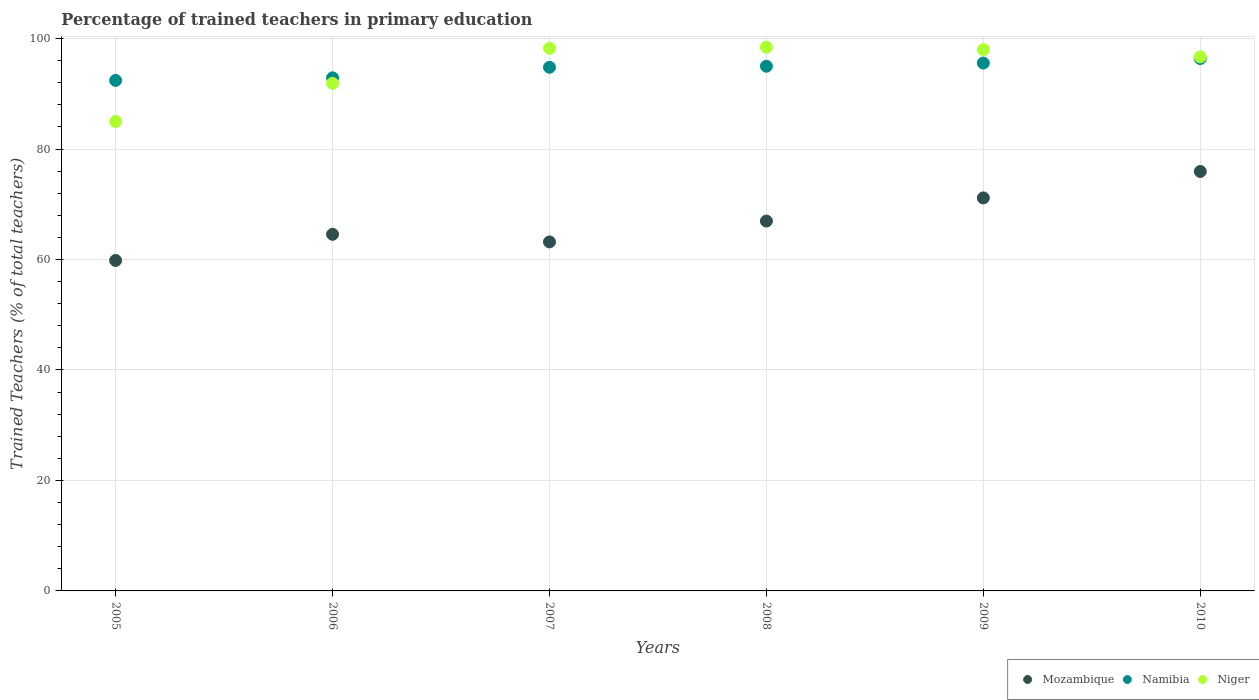Is the number of dotlines equal to the number of legend labels?
Ensure brevity in your answer.  Yes. What is the percentage of trained teachers in Mozambique in 2009?
Give a very brief answer. 71.16. Across all years, what is the maximum percentage of trained teachers in Niger?
Make the answer very short. 98.44. Across all years, what is the minimum percentage of trained teachers in Namibia?
Keep it short and to the point. 92.43. What is the total percentage of trained teachers in Namibia in the graph?
Your response must be concise. 567.1. What is the difference between the percentage of trained teachers in Mozambique in 2005 and that in 2008?
Your response must be concise. -7.13. What is the difference between the percentage of trained teachers in Niger in 2005 and the percentage of trained teachers in Mozambique in 2007?
Ensure brevity in your answer.  21.81. What is the average percentage of trained teachers in Namibia per year?
Give a very brief answer. 94.52. In the year 2008, what is the difference between the percentage of trained teachers in Mozambique and percentage of trained teachers in Niger?
Your response must be concise. -31.47. What is the ratio of the percentage of trained teachers in Niger in 2009 to that in 2010?
Your answer should be compact. 1.01. What is the difference between the highest and the second highest percentage of trained teachers in Mozambique?
Your answer should be compact. 4.79. What is the difference between the highest and the lowest percentage of trained teachers in Mozambique?
Offer a terse response. 16.11. Does the percentage of trained teachers in Mozambique monotonically increase over the years?
Offer a terse response. No. How many years are there in the graph?
Your response must be concise. 6. What is the difference between two consecutive major ticks on the Y-axis?
Offer a terse response. 20. Are the values on the major ticks of Y-axis written in scientific E-notation?
Offer a terse response. No. Does the graph contain any zero values?
Your answer should be compact. No. Does the graph contain grids?
Give a very brief answer. Yes. How many legend labels are there?
Your response must be concise. 3. How are the legend labels stacked?
Give a very brief answer. Horizontal. What is the title of the graph?
Provide a short and direct response. Percentage of trained teachers in primary education. Does "Malaysia" appear as one of the legend labels in the graph?
Provide a succinct answer. No. What is the label or title of the X-axis?
Give a very brief answer. Years. What is the label or title of the Y-axis?
Your answer should be very brief. Trained Teachers (% of total teachers). What is the Trained Teachers (% of total teachers) in Mozambique in 2005?
Your answer should be very brief. 59.83. What is the Trained Teachers (% of total teachers) of Namibia in 2005?
Keep it short and to the point. 92.43. What is the Trained Teachers (% of total teachers) of Niger in 2005?
Offer a very short reply. 85. What is the Trained Teachers (% of total teachers) in Mozambique in 2006?
Your answer should be very brief. 64.57. What is the Trained Teachers (% of total teachers) of Namibia in 2006?
Offer a terse response. 92.9. What is the Trained Teachers (% of total teachers) in Niger in 2006?
Keep it short and to the point. 91.91. What is the Trained Teachers (% of total teachers) in Mozambique in 2007?
Your answer should be very brief. 63.19. What is the Trained Teachers (% of total teachers) of Namibia in 2007?
Offer a terse response. 94.81. What is the Trained Teachers (% of total teachers) of Niger in 2007?
Offer a terse response. 98.24. What is the Trained Teachers (% of total teachers) of Mozambique in 2008?
Ensure brevity in your answer.  66.97. What is the Trained Teachers (% of total teachers) in Namibia in 2008?
Your response must be concise. 95. What is the Trained Teachers (% of total teachers) of Niger in 2008?
Your answer should be very brief. 98.44. What is the Trained Teachers (% of total teachers) of Mozambique in 2009?
Your answer should be very brief. 71.16. What is the Trained Teachers (% of total teachers) of Namibia in 2009?
Keep it short and to the point. 95.58. What is the Trained Teachers (% of total teachers) of Niger in 2009?
Your answer should be compact. 98.01. What is the Trained Teachers (% of total teachers) in Mozambique in 2010?
Give a very brief answer. 75.94. What is the Trained Teachers (% of total teachers) of Namibia in 2010?
Offer a terse response. 96.39. What is the Trained Teachers (% of total teachers) of Niger in 2010?
Ensure brevity in your answer.  96.69. Across all years, what is the maximum Trained Teachers (% of total teachers) of Mozambique?
Offer a very short reply. 75.94. Across all years, what is the maximum Trained Teachers (% of total teachers) in Namibia?
Give a very brief answer. 96.39. Across all years, what is the maximum Trained Teachers (% of total teachers) in Niger?
Keep it short and to the point. 98.44. Across all years, what is the minimum Trained Teachers (% of total teachers) in Mozambique?
Ensure brevity in your answer.  59.83. Across all years, what is the minimum Trained Teachers (% of total teachers) of Namibia?
Make the answer very short. 92.43. Across all years, what is the minimum Trained Teachers (% of total teachers) of Niger?
Your response must be concise. 85. What is the total Trained Teachers (% of total teachers) in Mozambique in the graph?
Give a very brief answer. 401.66. What is the total Trained Teachers (% of total teachers) of Namibia in the graph?
Make the answer very short. 567.1. What is the total Trained Teachers (% of total teachers) of Niger in the graph?
Offer a very short reply. 568.29. What is the difference between the Trained Teachers (% of total teachers) of Mozambique in 2005 and that in 2006?
Offer a very short reply. -4.73. What is the difference between the Trained Teachers (% of total teachers) in Namibia in 2005 and that in 2006?
Make the answer very short. -0.47. What is the difference between the Trained Teachers (% of total teachers) in Niger in 2005 and that in 2006?
Ensure brevity in your answer.  -6.91. What is the difference between the Trained Teachers (% of total teachers) of Mozambique in 2005 and that in 2007?
Your answer should be compact. -3.36. What is the difference between the Trained Teachers (% of total teachers) of Namibia in 2005 and that in 2007?
Provide a succinct answer. -2.38. What is the difference between the Trained Teachers (% of total teachers) of Niger in 2005 and that in 2007?
Make the answer very short. -13.24. What is the difference between the Trained Teachers (% of total teachers) in Mozambique in 2005 and that in 2008?
Make the answer very short. -7.13. What is the difference between the Trained Teachers (% of total teachers) of Namibia in 2005 and that in 2008?
Offer a terse response. -2.57. What is the difference between the Trained Teachers (% of total teachers) of Niger in 2005 and that in 2008?
Offer a terse response. -13.44. What is the difference between the Trained Teachers (% of total teachers) of Mozambique in 2005 and that in 2009?
Offer a terse response. -11.32. What is the difference between the Trained Teachers (% of total teachers) in Namibia in 2005 and that in 2009?
Provide a short and direct response. -3.15. What is the difference between the Trained Teachers (% of total teachers) in Niger in 2005 and that in 2009?
Provide a short and direct response. -13.01. What is the difference between the Trained Teachers (% of total teachers) of Mozambique in 2005 and that in 2010?
Your answer should be compact. -16.11. What is the difference between the Trained Teachers (% of total teachers) in Namibia in 2005 and that in 2010?
Make the answer very short. -3.96. What is the difference between the Trained Teachers (% of total teachers) of Niger in 2005 and that in 2010?
Provide a succinct answer. -11.69. What is the difference between the Trained Teachers (% of total teachers) of Mozambique in 2006 and that in 2007?
Make the answer very short. 1.38. What is the difference between the Trained Teachers (% of total teachers) of Namibia in 2006 and that in 2007?
Your answer should be compact. -1.91. What is the difference between the Trained Teachers (% of total teachers) of Niger in 2006 and that in 2007?
Offer a very short reply. -6.33. What is the difference between the Trained Teachers (% of total teachers) in Mozambique in 2006 and that in 2008?
Give a very brief answer. -2.4. What is the difference between the Trained Teachers (% of total teachers) in Namibia in 2006 and that in 2008?
Your response must be concise. -2.1. What is the difference between the Trained Teachers (% of total teachers) of Niger in 2006 and that in 2008?
Make the answer very short. -6.53. What is the difference between the Trained Teachers (% of total teachers) of Mozambique in 2006 and that in 2009?
Provide a succinct answer. -6.59. What is the difference between the Trained Teachers (% of total teachers) in Namibia in 2006 and that in 2009?
Give a very brief answer. -2.68. What is the difference between the Trained Teachers (% of total teachers) in Niger in 2006 and that in 2009?
Your answer should be very brief. -6.11. What is the difference between the Trained Teachers (% of total teachers) in Mozambique in 2006 and that in 2010?
Provide a succinct answer. -11.38. What is the difference between the Trained Teachers (% of total teachers) of Namibia in 2006 and that in 2010?
Provide a succinct answer. -3.49. What is the difference between the Trained Teachers (% of total teachers) of Niger in 2006 and that in 2010?
Offer a terse response. -4.79. What is the difference between the Trained Teachers (% of total teachers) in Mozambique in 2007 and that in 2008?
Make the answer very short. -3.78. What is the difference between the Trained Teachers (% of total teachers) of Namibia in 2007 and that in 2008?
Give a very brief answer. -0.19. What is the difference between the Trained Teachers (% of total teachers) of Niger in 2007 and that in 2008?
Your response must be concise. -0.2. What is the difference between the Trained Teachers (% of total teachers) of Mozambique in 2007 and that in 2009?
Your answer should be compact. -7.97. What is the difference between the Trained Teachers (% of total teachers) of Namibia in 2007 and that in 2009?
Ensure brevity in your answer.  -0.77. What is the difference between the Trained Teachers (% of total teachers) of Niger in 2007 and that in 2009?
Offer a very short reply. 0.22. What is the difference between the Trained Teachers (% of total teachers) of Mozambique in 2007 and that in 2010?
Give a very brief answer. -12.75. What is the difference between the Trained Teachers (% of total teachers) in Namibia in 2007 and that in 2010?
Your answer should be compact. -1.58. What is the difference between the Trained Teachers (% of total teachers) of Niger in 2007 and that in 2010?
Keep it short and to the point. 1.54. What is the difference between the Trained Teachers (% of total teachers) in Mozambique in 2008 and that in 2009?
Provide a short and direct response. -4.19. What is the difference between the Trained Teachers (% of total teachers) of Namibia in 2008 and that in 2009?
Keep it short and to the point. -0.58. What is the difference between the Trained Teachers (% of total teachers) of Niger in 2008 and that in 2009?
Your response must be concise. 0.42. What is the difference between the Trained Teachers (% of total teachers) of Mozambique in 2008 and that in 2010?
Give a very brief answer. -8.98. What is the difference between the Trained Teachers (% of total teachers) of Namibia in 2008 and that in 2010?
Give a very brief answer. -1.39. What is the difference between the Trained Teachers (% of total teachers) in Niger in 2008 and that in 2010?
Offer a very short reply. 1.74. What is the difference between the Trained Teachers (% of total teachers) of Mozambique in 2009 and that in 2010?
Provide a short and direct response. -4.79. What is the difference between the Trained Teachers (% of total teachers) of Namibia in 2009 and that in 2010?
Offer a terse response. -0.81. What is the difference between the Trained Teachers (% of total teachers) of Niger in 2009 and that in 2010?
Make the answer very short. 1.32. What is the difference between the Trained Teachers (% of total teachers) of Mozambique in 2005 and the Trained Teachers (% of total teachers) of Namibia in 2006?
Your response must be concise. -33.07. What is the difference between the Trained Teachers (% of total teachers) of Mozambique in 2005 and the Trained Teachers (% of total teachers) of Niger in 2006?
Your answer should be very brief. -32.08. What is the difference between the Trained Teachers (% of total teachers) of Namibia in 2005 and the Trained Teachers (% of total teachers) of Niger in 2006?
Ensure brevity in your answer.  0.52. What is the difference between the Trained Teachers (% of total teachers) of Mozambique in 2005 and the Trained Teachers (% of total teachers) of Namibia in 2007?
Provide a short and direct response. -34.98. What is the difference between the Trained Teachers (% of total teachers) in Mozambique in 2005 and the Trained Teachers (% of total teachers) in Niger in 2007?
Your answer should be compact. -38.4. What is the difference between the Trained Teachers (% of total teachers) of Namibia in 2005 and the Trained Teachers (% of total teachers) of Niger in 2007?
Ensure brevity in your answer.  -5.81. What is the difference between the Trained Teachers (% of total teachers) in Mozambique in 2005 and the Trained Teachers (% of total teachers) in Namibia in 2008?
Provide a short and direct response. -35.17. What is the difference between the Trained Teachers (% of total teachers) of Mozambique in 2005 and the Trained Teachers (% of total teachers) of Niger in 2008?
Offer a terse response. -38.6. What is the difference between the Trained Teachers (% of total teachers) in Namibia in 2005 and the Trained Teachers (% of total teachers) in Niger in 2008?
Give a very brief answer. -6.01. What is the difference between the Trained Teachers (% of total teachers) of Mozambique in 2005 and the Trained Teachers (% of total teachers) of Namibia in 2009?
Provide a short and direct response. -35.74. What is the difference between the Trained Teachers (% of total teachers) of Mozambique in 2005 and the Trained Teachers (% of total teachers) of Niger in 2009?
Your answer should be very brief. -38.18. What is the difference between the Trained Teachers (% of total teachers) of Namibia in 2005 and the Trained Teachers (% of total teachers) of Niger in 2009?
Give a very brief answer. -5.59. What is the difference between the Trained Teachers (% of total teachers) in Mozambique in 2005 and the Trained Teachers (% of total teachers) in Namibia in 2010?
Your answer should be compact. -36.56. What is the difference between the Trained Teachers (% of total teachers) in Mozambique in 2005 and the Trained Teachers (% of total teachers) in Niger in 2010?
Make the answer very short. -36.86. What is the difference between the Trained Teachers (% of total teachers) of Namibia in 2005 and the Trained Teachers (% of total teachers) of Niger in 2010?
Offer a very short reply. -4.27. What is the difference between the Trained Teachers (% of total teachers) of Mozambique in 2006 and the Trained Teachers (% of total teachers) of Namibia in 2007?
Keep it short and to the point. -30.24. What is the difference between the Trained Teachers (% of total teachers) of Mozambique in 2006 and the Trained Teachers (% of total teachers) of Niger in 2007?
Your answer should be compact. -33.67. What is the difference between the Trained Teachers (% of total teachers) of Namibia in 2006 and the Trained Teachers (% of total teachers) of Niger in 2007?
Provide a short and direct response. -5.34. What is the difference between the Trained Teachers (% of total teachers) of Mozambique in 2006 and the Trained Teachers (% of total teachers) of Namibia in 2008?
Your answer should be very brief. -30.43. What is the difference between the Trained Teachers (% of total teachers) of Mozambique in 2006 and the Trained Teachers (% of total teachers) of Niger in 2008?
Your answer should be very brief. -33.87. What is the difference between the Trained Teachers (% of total teachers) of Namibia in 2006 and the Trained Teachers (% of total teachers) of Niger in 2008?
Ensure brevity in your answer.  -5.54. What is the difference between the Trained Teachers (% of total teachers) of Mozambique in 2006 and the Trained Teachers (% of total teachers) of Namibia in 2009?
Make the answer very short. -31.01. What is the difference between the Trained Teachers (% of total teachers) of Mozambique in 2006 and the Trained Teachers (% of total teachers) of Niger in 2009?
Provide a succinct answer. -33.45. What is the difference between the Trained Teachers (% of total teachers) in Namibia in 2006 and the Trained Teachers (% of total teachers) in Niger in 2009?
Your answer should be very brief. -5.12. What is the difference between the Trained Teachers (% of total teachers) of Mozambique in 2006 and the Trained Teachers (% of total teachers) of Namibia in 2010?
Give a very brief answer. -31.82. What is the difference between the Trained Teachers (% of total teachers) in Mozambique in 2006 and the Trained Teachers (% of total teachers) in Niger in 2010?
Your answer should be very brief. -32.13. What is the difference between the Trained Teachers (% of total teachers) in Namibia in 2006 and the Trained Teachers (% of total teachers) in Niger in 2010?
Offer a very short reply. -3.8. What is the difference between the Trained Teachers (% of total teachers) of Mozambique in 2007 and the Trained Teachers (% of total teachers) of Namibia in 2008?
Keep it short and to the point. -31.81. What is the difference between the Trained Teachers (% of total teachers) in Mozambique in 2007 and the Trained Teachers (% of total teachers) in Niger in 2008?
Keep it short and to the point. -35.25. What is the difference between the Trained Teachers (% of total teachers) of Namibia in 2007 and the Trained Teachers (% of total teachers) of Niger in 2008?
Your answer should be compact. -3.63. What is the difference between the Trained Teachers (% of total teachers) in Mozambique in 2007 and the Trained Teachers (% of total teachers) in Namibia in 2009?
Give a very brief answer. -32.38. What is the difference between the Trained Teachers (% of total teachers) of Mozambique in 2007 and the Trained Teachers (% of total teachers) of Niger in 2009?
Provide a short and direct response. -34.82. What is the difference between the Trained Teachers (% of total teachers) of Namibia in 2007 and the Trained Teachers (% of total teachers) of Niger in 2009?
Ensure brevity in your answer.  -3.21. What is the difference between the Trained Teachers (% of total teachers) of Mozambique in 2007 and the Trained Teachers (% of total teachers) of Namibia in 2010?
Offer a very short reply. -33.2. What is the difference between the Trained Teachers (% of total teachers) of Mozambique in 2007 and the Trained Teachers (% of total teachers) of Niger in 2010?
Offer a very short reply. -33.5. What is the difference between the Trained Teachers (% of total teachers) of Namibia in 2007 and the Trained Teachers (% of total teachers) of Niger in 2010?
Give a very brief answer. -1.89. What is the difference between the Trained Teachers (% of total teachers) of Mozambique in 2008 and the Trained Teachers (% of total teachers) of Namibia in 2009?
Offer a terse response. -28.61. What is the difference between the Trained Teachers (% of total teachers) of Mozambique in 2008 and the Trained Teachers (% of total teachers) of Niger in 2009?
Keep it short and to the point. -31.05. What is the difference between the Trained Teachers (% of total teachers) in Namibia in 2008 and the Trained Teachers (% of total teachers) in Niger in 2009?
Give a very brief answer. -3.02. What is the difference between the Trained Teachers (% of total teachers) of Mozambique in 2008 and the Trained Teachers (% of total teachers) of Namibia in 2010?
Your answer should be compact. -29.42. What is the difference between the Trained Teachers (% of total teachers) of Mozambique in 2008 and the Trained Teachers (% of total teachers) of Niger in 2010?
Provide a short and direct response. -29.73. What is the difference between the Trained Teachers (% of total teachers) of Namibia in 2008 and the Trained Teachers (% of total teachers) of Niger in 2010?
Make the answer very short. -1.7. What is the difference between the Trained Teachers (% of total teachers) in Mozambique in 2009 and the Trained Teachers (% of total teachers) in Namibia in 2010?
Make the answer very short. -25.23. What is the difference between the Trained Teachers (% of total teachers) in Mozambique in 2009 and the Trained Teachers (% of total teachers) in Niger in 2010?
Provide a short and direct response. -25.54. What is the difference between the Trained Teachers (% of total teachers) in Namibia in 2009 and the Trained Teachers (% of total teachers) in Niger in 2010?
Make the answer very short. -1.12. What is the average Trained Teachers (% of total teachers) of Mozambique per year?
Your response must be concise. 66.94. What is the average Trained Teachers (% of total teachers) of Namibia per year?
Your answer should be very brief. 94.52. What is the average Trained Teachers (% of total teachers) of Niger per year?
Ensure brevity in your answer.  94.72. In the year 2005, what is the difference between the Trained Teachers (% of total teachers) in Mozambique and Trained Teachers (% of total teachers) in Namibia?
Give a very brief answer. -32.59. In the year 2005, what is the difference between the Trained Teachers (% of total teachers) in Mozambique and Trained Teachers (% of total teachers) in Niger?
Your response must be concise. -25.17. In the year 2005, what is the difference between the Trained Teachers (% of total teachers) in Namibia and Trained Teachers (% of total teachers) in Niger?
Make the answer very short. 7.43. In the year 2006, what is the difference between the Trained Teachers (% of total teachers) in Mozambique and Trained Teachers (% of total teachers) in Namibia?
Your response must be concise. -28.33. In the year 2006, what is the difference between the Trained Teachers (% of total teachers) in Mozambique and Trained Teachers (% of total teachers) in Niger?
Offer a terse response. -27.34. In the year 2006, what is the difference between the Trained Teachers (% of total teachers) in Namibia and Trained Teachers (% of total teachers) in Niger?
Keep it short and to the point. 0.99. In the year 2007, what is the difference between the Trained Teachers (% of total teachers) in Mozambique and Trained Teachers (% of total teachers) in Namibia?
Your answer should be compact. -31.62. In the year 2007, what is the difference between the Trained Teachers (% of total teachers) of Mozambique and Trained Teachers (% of total teachers) of Niger?
Ensure brevity in your answer.  -35.04. In the year 2007, what is the difference between the Trained Teachers (% of total teachers) in Namibia and Trained Teachers (% of total teachers) in Niger?
Keep it short and to the point. -3.43. In the year 2008, what is the difference between the Trained Teachers (% of total teachers) in Mozambique and Trained Teachers (% of total teachers) in Namibia?
Your response must be concise. -28.03. In the year 2008, what is the difference between the Trained Teachers (% of total teachers) in Mozambique and Trained Teachers (% of total teachers) in Niger?
Provide a short and direct response. -31.47. In the year 2008, what is the difference between the Trained Teachers (% of total teachers) in Namibia and Trained Teachers (% of total teachers) in Niger?
Make the answer very short. -3.44. In the year 2009, what is the difference between the Trained Teachers (% of total teachers) in Mozambique and Trained Teachers (% of total teachers) in Namibia?
Keep it short and to the point. -24.42. In the year 2009, what is the difference between the Trained Teachers (% of total teachers) of Mozambique and Trained Teachers (% of total teachers) of Niger?
Provide a short and direct response. -26.86. In the year 2009, what is the difference between the Trained Teachers (% of total teachers) in Namibia and Trained Teachers (% of total teachers) in Niger?
Keep it short and to the point. -2.44. In the year 2010, what is the difference between the Trained Teachers (% of total teachers) in Mozambique and Trained Teachers (% of total teachers) in Namibia?
Offer a terse response. -20.45. In the year 2010, what is the difference between the Trained Teachers (% of total teachers) in Mozambique and Trained Teachers (% of total teachers) in Niger?
Provide a short and direct response. -20.75. In the year 2010, what is the difference between the Trained Teachers (% of total teachers) of Namibia and Trained Teachers (% of total teachers) of Niger?
Your answer should be very brief. -0.31. What is the ratio of the Trained Teachers (% of total teachers) in Mozambique in 2005 to that in 2006?
Offer a very short reply. 0.93. What is the ratio of the Trained Teachers (% of total teachers) in Niger in 2005 to that in 2006?
Keep it short and to the point. 0.92. What is the ratio of the Trained Teachers (% of total teachers) in Mozambique in 2005 to that in 2007?
Ensure brevity in your answer.  0.95. What is the ratio of the Trained Teachers (% of total teachers) in Namibia in 2005 to that in 2007?
Provide a succinct answer. 0.97. What is the ratio of the Trained Teachers (% of total teachers) of Niger in 2005 to that in 2007?
Offer a terse response. 0.87. What is the ratio of the Trained Teachers (% of total teachers) in Mozambique in 2005 to that in 2008?
Ensure brevity in your answer.  0.89. What is the ratio of the Trained Teachers (% of total teachers) of Namibia in 2005 to that in 2008?
Keep it short and to the point. 0.97. What is the ratio of the Trained Teachers (% of total teachers) in Niger in 2005 to that in 2008?
Keep it short and to the point. 0.86. What is the ratio of the Trained Teachers (% of total teachers) in Mozambique in 2005 to that in 2009?
Offer a terse response. 0.84. What is the ratio of the Trained Teachers (% of total teachers) in Namibia in 2005 to that in 2009?
Provide a short and direct response. 0.97. What is the ratio of the Trained Teachers (% of total teachers) of Niger in 2005 to that in 2009?
Offer a terse response. 0.87. What is the ratio of the Trained Teachers (% of total teachers) in Mozambique in 2005 to that in 2010?
Offer a very short reply. 0.79. What is the ratio of the Trained Teachers (% of total teachers) in Namibia in 2005 to that in 2010?
Your response must be concise. 0.96. What is the ratio of the Trained Teachers (% of total teachers) in Niger in 2005 to that in 2010?
Provide a short and direct response. 0.88. What is the ratio of the Trained Teachers (% of total teachers) of Mozambique in 2006 to that in 2007?
Offer a very short reply. 1.02. What is the ratio of the Trained Teachers (% of total teachers) of Namibia in 2006 to that in 2007?
Provide a short and direct response. 0.98. What is the ratio of the Trained Teachers (% of total teachers) of Niger in 2006 to that in 2007?
Ensure brevity in your answer.  0.94. What is the ratio of the Trained Teachers (% of total teachers) of Mozambique in 2006 to that in 2008?
Make the answer very short. 0.96. What is the ratio of the Trained Teachers (% of total teachers) of Namibia in 2006 to that in 2008?
Ensure brevity in your answer.  0.98. What is the ratio of the Trained Teachers (% of total teachers) in Niger in 2006 to that in 2008?
Provide a succinct answer. 0.93. What is the ratio of the Trained Teachers (% of total teachers) of Mozambique in 2006 to that in 2009?
Provide a short and direct response. 0.91. What is the ratio of the Trained Teachers (% of total teachers) in Namibia in 2006 to that in 2009?
Your response must be concise. 0.97. What is the ratio of the Trained Teachers (% of total teachers) in Niger in 2006 to that in 2009?
Your response must be concise. 0.94. What is the ratio of the Trained Teachers (% of total teachers) in Mozambique in 2006 to that in 2010?
Keep it short and to the point. 0.85. What is the ratio of the Trained Teachers (% of total teachers) in Namibia in 2006 to that in 2010?
Your answer should be very brief. 0.96. What is the ratio of the Trained Teachers (% of total teachers) of Niger in 2006 to that in 2010?
Offer a terse response. 0.95. What is the ratio of the Trained Teachers (% of total teachers) of Mozambique in 2007 to that in 2008?
Provide a short and direct response. 0.94. What is the ratio of the Trained Teachers (% of total teachers) in Namibia in 2007 to that in 2008?
Provide a short and direct response. 1. What is the ratio of the Trained Teachers (% of total teachers) in Mozambique in 2007 to that in 2009?
Offer a very short reply. 0.89. What is the ratio of the Trained Teachers (% of total teachers) of Namibia in 2007 to that in 2009?
Offer a terse response. 0.99. What is the ratio of the Trained Teachers (% of total teachers) of Niger in 2007 to that in 2009?
Keep it short and to the point. 1. What is the ratio of the Trained Teachers (% of total teachers) of Mozambique in 2007 to that in 2010?
Your answer should be compact. 0.83. What is the ratio of the Trained Teachers (% of total teachers) in Namibia in 2007 to that in 2010?
Keep it short and to the point. 0.98. What is the ratio of the Trained Teachers (% of total teachers) in Niger in 2007 to that in 2010?
Offer a very short reply. 1.02. What is the ratio of the Trained Teachers (% of total teachers) of Mozambique in 2008 to that in 2009?
Offer a terse response. 0.94. What is the ratio of the Trained Teachers (% of total teachers) of Namibia in 2008 to that in 2009?
Make the answer very short. 0.99. What is the ratio of the Trained Teachers (% of total teachers) of Niger in 2008 to that in 2009?
Keep it short and to the point. 1. What is the ratio of the Trained Teachers (% of total teachers) of Mozambique in 2008 to that in 2010?
Offer a very short reply. 0.88. What is the ratio of the Trained Teachers (% of total teachers) in Namibia in 2008 to that in 2010?
Your response must be concise. 0.99. What is the ratio of the Trained Teachers (% of total teachers) of Mozambique in 2009 to that in 2010?
Offer a terse response. 0.94. What is the ratio of the Trained Teachers (% of total teachers) of Namibia in 2009 to that in 2010?
Your answer should be very brief. 0.99. What is the ratio of the Trained Teachers (% of total teachers) of Niger in 2009 to that in 2010?
Offer a very short reply. 1.01. What is the difference between the highest and the second highest Trained Teachers (% of total teachers) in Mozambique?
Your answer should be compact. 4.79. What is the difference between the highest and the second highest Trained Teachers (% of total teachers) of Namibia?
Offer a very short reply. 0.81. What is the difference between the highest and the second highest Trained Teachers (% of total teachers) in Niger?
Give a very brief answer. 0.2. What is the difference between the highest and the lowest Trained Teachers (% of total teachers) in Mozambique?
Keep it short and to the point. 16.11. What is the difference between the highest and the lowest Trained Teachers (% of total teachers) of Namibia?
Offer a terse response. 3.96. What is the difference between the highest and the lowest Trained Teachers (% of total teachers) of Niger?
Make the answer very short. 13.44. 